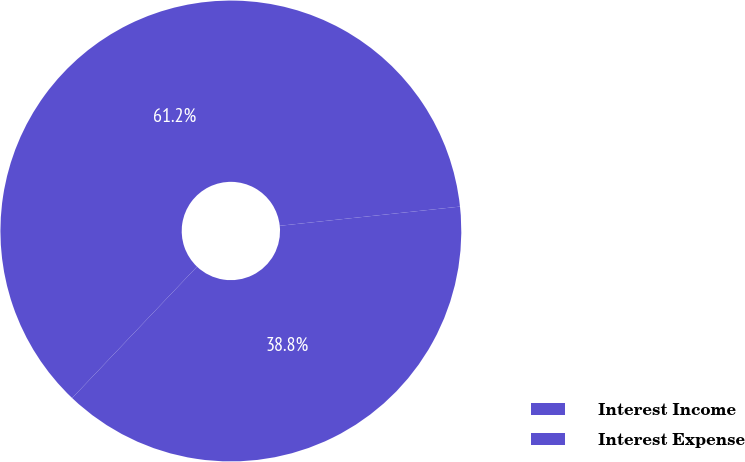<chart> <loc_0><loc_0><loc_500><loc_500><pie_chart><fcel>Interest Income<fcel>Interest Expense<nl><fcel>38.78%<fcel>61.22%<nl></chart> 